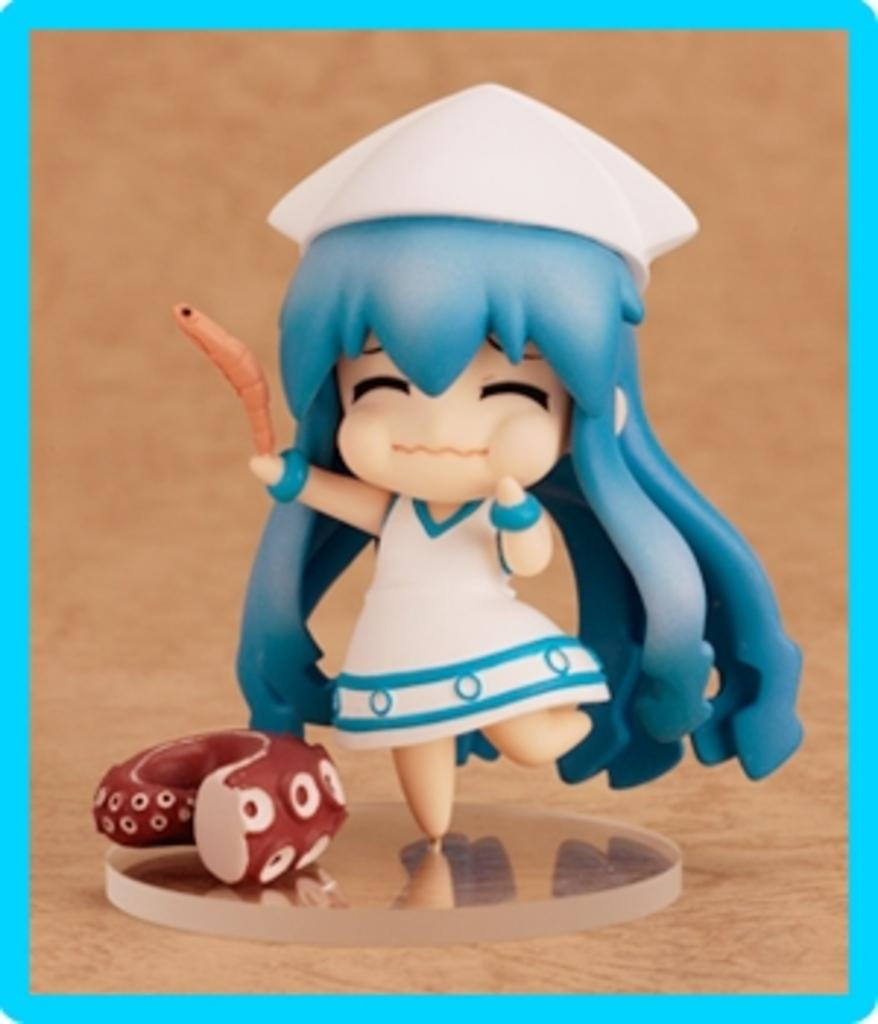What object can be seen in the image? There is a toy in the image. Where is the toy located? The toy is on a platform. What scientific theory is being demonstrated by the toy in the image? There is no scientific theory being demonstrated by the toy in the image. 